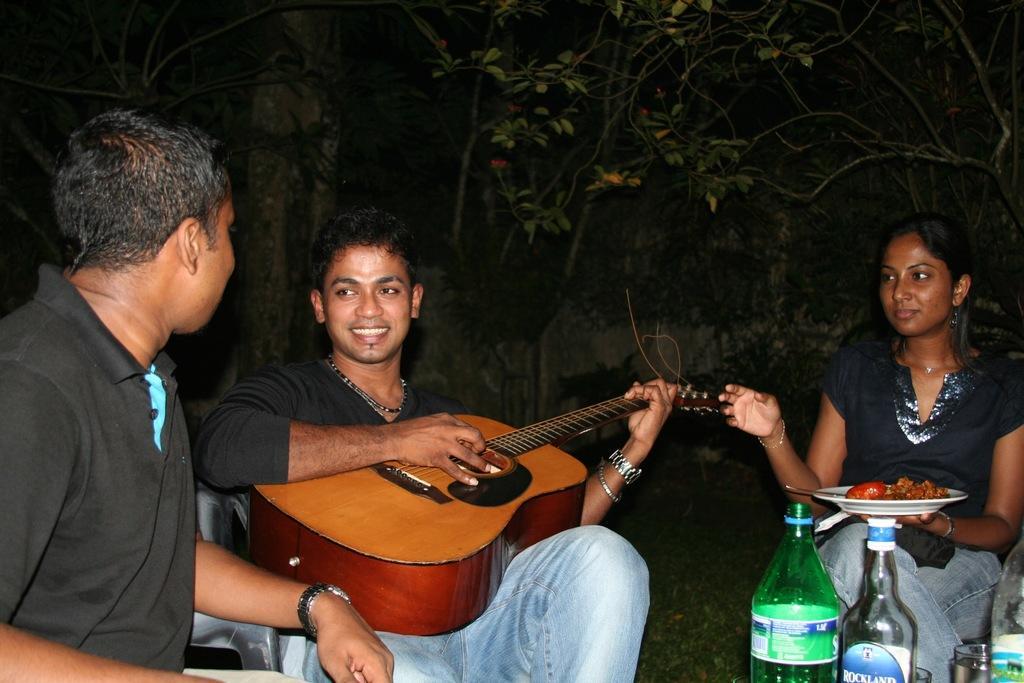How would you summarize this image in a sentence or two? this is an image clicked in the dark. Here I can see two men are wearing black color dress and sitting on the chairs. On the right side of the image I can see a woman sitting on the chair and holding a plate with some food. On the right bottom of the side I can see few bottles. A man who is in the middle is holding a guitar in his hands and smiling. 